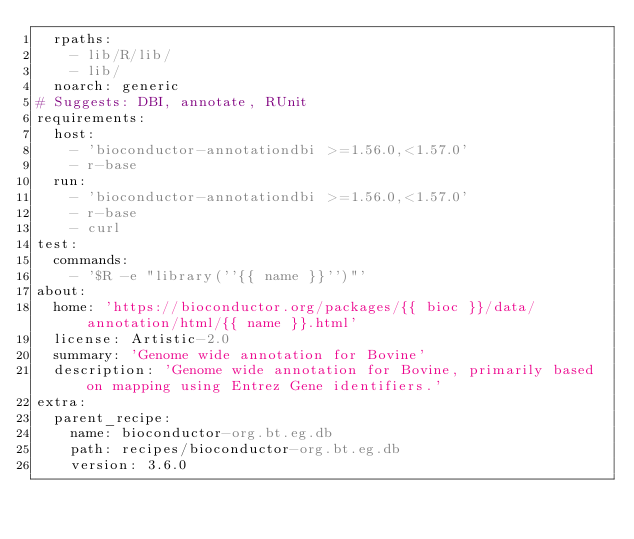Convert code to text. <code><loc_0><loc_0><loc_500><loc_500><_YAML_>  rpaths:
    - lib/R/lib/
    - lib/
  noarch: generic
# Suggests: DBI, annotate, RUnit
requirements:
  host:
    - 'bioconductor-annotationdbi >=1.56.0,<1.57.0'
    - r-base
  run:
    - 'bioconductor-annotationdbi >=1.56.0,<1.57.0'
    - r-base
    - curl
test:
  commands:
    - '$R -e "library(''{{ name }}'')"'
about:
  home: 'https://bioconductor.org/packages/{{ bioc }}/data/annotation/html/{{ name }}.html'
  license: Artistic-2.0
  summary: 'Genome wide annotation for Bovine'
  description: 'Genome wide annotation for Bovine, primarily based on mapping using Entrez Gene identifiers.'
extra:
  parent_recipe:
    name: bioconductor-org.bt.eg.db
    path: recipes/bioconductor-org.bt.eg.db
    version: 3.6.0

</code> 